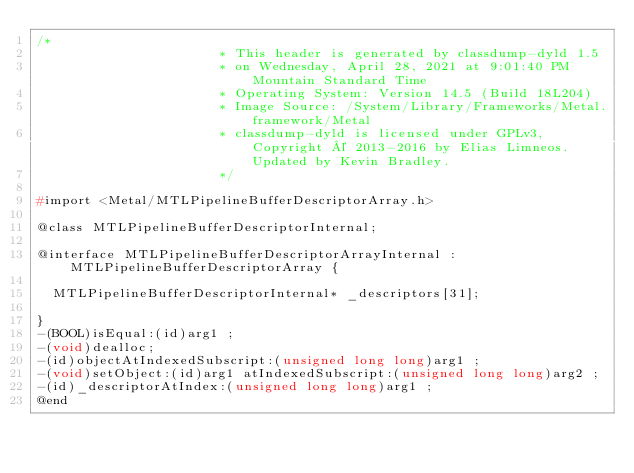<code> <loc_0><loc_0><loc_500><loc_500><_C_>/*
                       * This header is generated by classdump-dyld 1.5
                       * on Wednesday, April 28, 2021 at 9:01:40 PM Mountain Standard Time
                       * Operating System: Version 14.5 (Build 18L204)
                       * Image Source: /System/Library/Frameworks/Metal.framework/Metal
                       * classdump-dyld is licensed under GPLv3, Copyright © 2013-2016 by Elias Limneos. Updated by Kevin Bradley.
                       */

#import <Metal/MTLPipelineBufferDescriptorArray.h>

@class MTLPipelineBufferDescriptorInternal;

@interface MTLPipelineBufferDescriptorArrayInternal : MTLPipelineBufferDescriptorArray {

	MTLPipelineBufferDescriptorInternal* _descriptors[31];

}
-(BOOL)isEqual:(id)arg1 ;
-(void)dealloc;
-(id)objectAtIndexedSubscript:(unsigned long long)arg1 ;
-(void)setObject:(id)arg1 atIndexedSubscript:(unsigned long long)arg2 ;
-(id)_descriptorAtIndex:(unsigned long long)arg1 ;
@end

</code> 